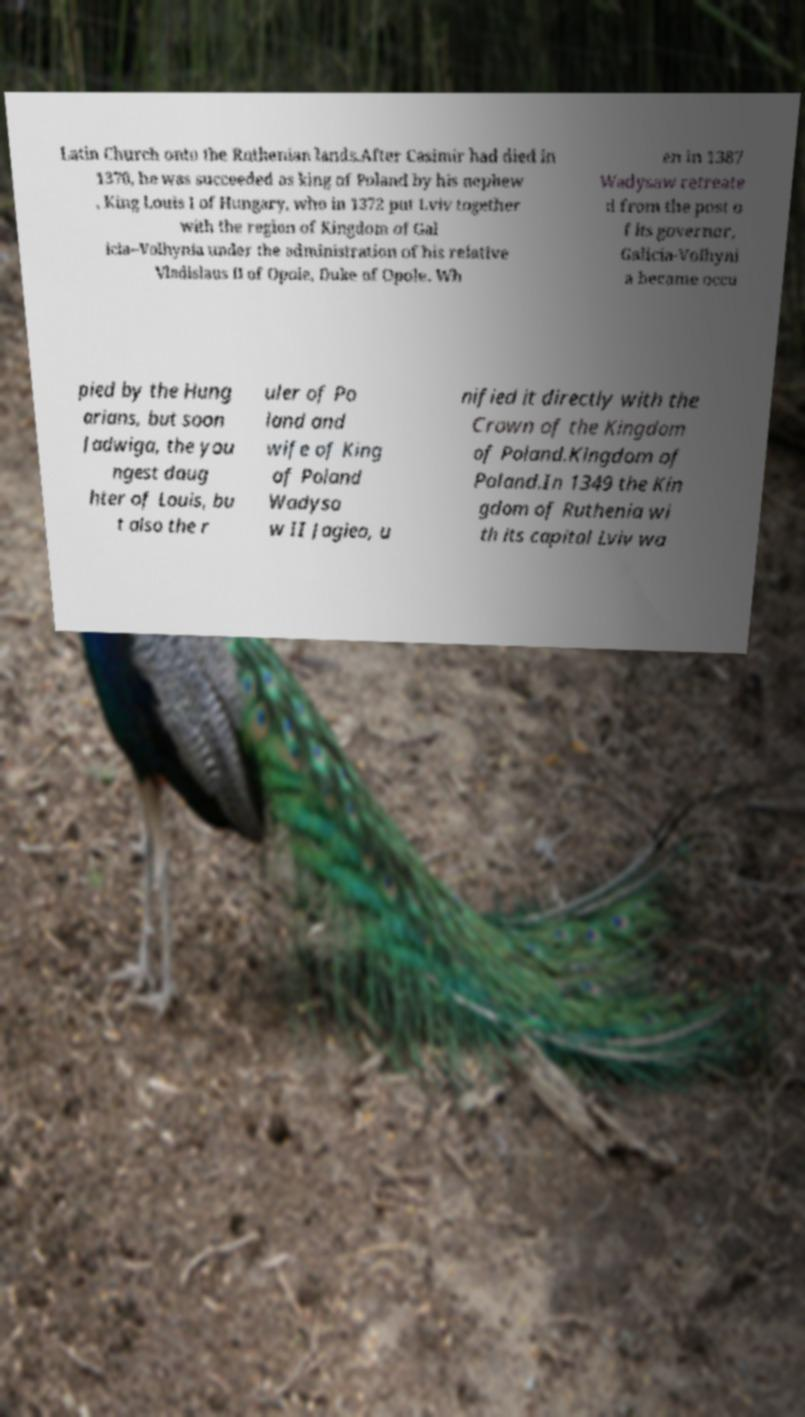For documentation purposes, I need the text within this image transcribed. Could you provide that? Latin Church onto the Ruthenian lands.After Casimir had died in 1370, he was succeeded as king of Poland by his nephew , King Louis I of Hungary, who in 1372 put Lviv together with the region of Kingdom of Gal icia–Volhynia under the administration of his relative Vladislaus II of Opole, Duke of Opole. Wh en in 1387 Wadysaw retreate d from the post o f its governor, Galicia-Volhyni a became occu pied by the Hung arians, but soon Jadwiga, the you ngest daug hter of Louis, bu t also the r uler of Po land and wife of King of Poland Wadysa w II Jagieo, u nified it directly with the Crown of the Kingdom of Poland.Kingdom of Poland.In 1349 the Kin gdom of Ruthenia wi th its capital Lviv wa 